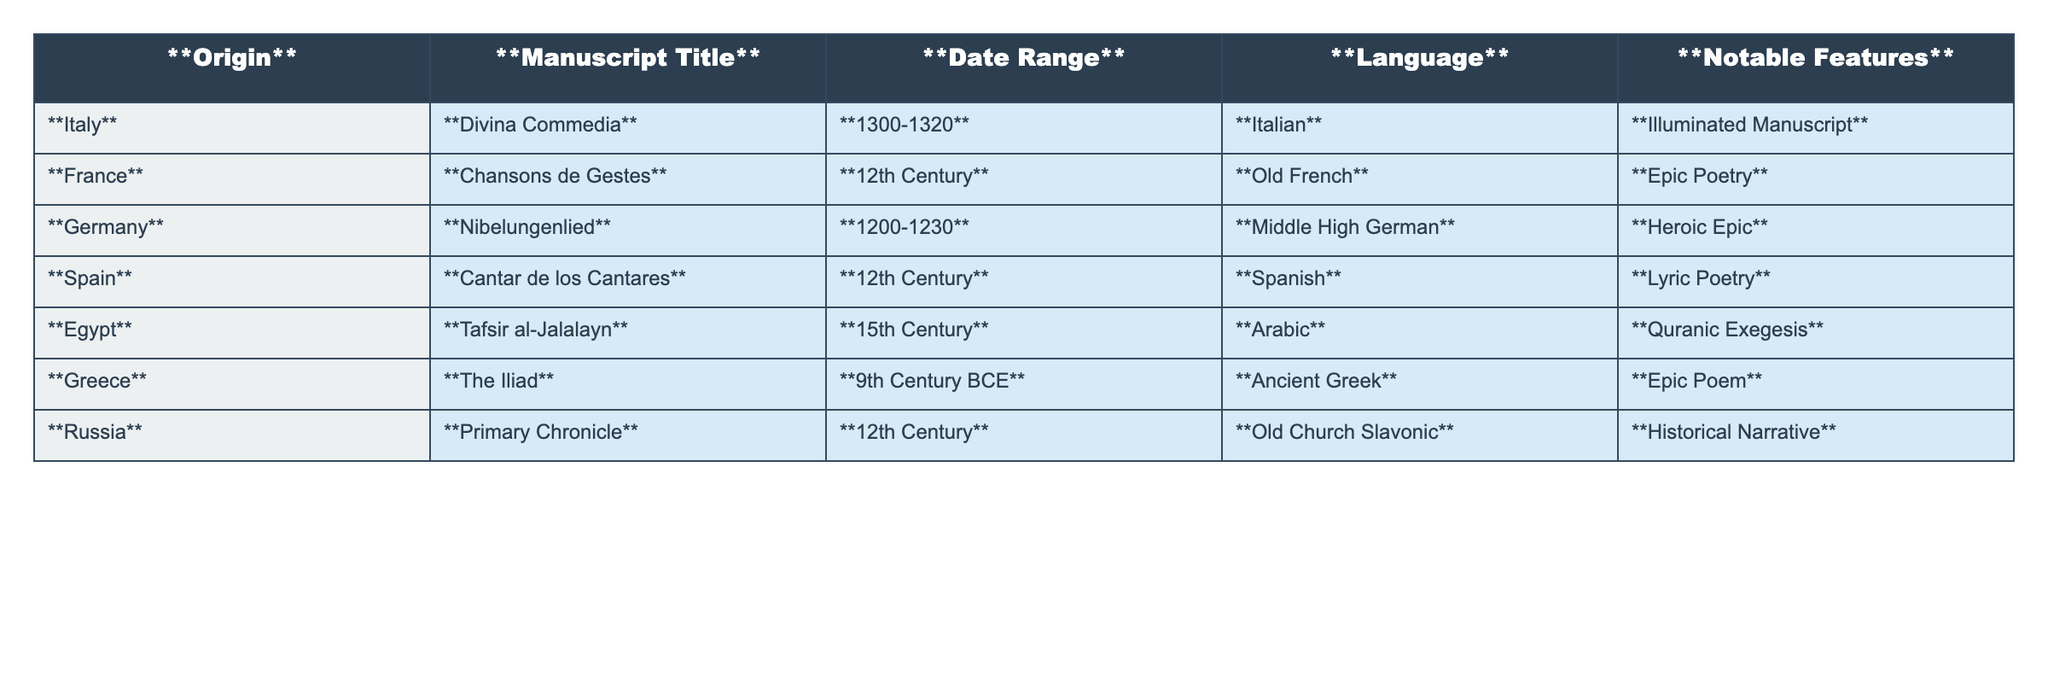What is the title of the manuscript from Egypt? The table lists the manuscripts by origin, and the entry for Egypt shows the manuscript titled "Tafsir al-Jalalayn."
Answer: Tafsir al-Jalalayn Which manuscript is written in Ancient Greek? Looking at the Language column, the entry for Ancient Greek corresponds to the manuscript titled "The Iliad" under Greece.
Answer: The Iliad How many manuscripts are from the 12th Century? The table lists two manuscripts dated to the 12th Century: "Chansons de Gestes" from France and "Cantar de los Cantares" from Spain.
Answer: Two Is the "Divina Commedia" an illuminated manuscript? The table indicates that "Divina Commedia," which is from Italy, has the notable feature of being an illuminated manuscript, confirming that it is indeed illuminated.
Answer: Yes What notable feature is associated with the "Nibelungenlied"? By reviewing the notable features column, it states that "Nibelungenlied," from Germany, is categorized as a heroic epic.
Answer: Heroic Epic What is the range of dates for the manuscript from Greece? The table shows that the manuscript "The Iliad" from Greece has a date range of "9th Century BCE."
Answer: 9th Century BCE Which language is used in the "Primary Chronicle"? The table indicates that the "Primary Chronicle," originating from Russia, is written in Old Church Slavonic.
Answer: Old Church Slavonic How many manuscripts are written in languages that are classified as Romance languages? Analyzing the table: "Divina Commedia" (Italian), "Chansons de Gestes" (Old French), and "Cantar de los Cantares" (Spanish) are all Romance languages, totaling three manuscripts.
Answer: Three What is the earliest date range among the manuscripts listed? Upon reviewing the date ranges, "The Iliad" from Greece is dated to the 9th Century BCE, making it the earliest.
Answer: 9th Century BCE Which origin has a manuscript that focuses on Quranic exegesis? From the table, it is evident that Egypt has a manuscript titled "Tafsir al-Jalalayn," which focuses on Quranic exegesis.
Answer: Egypt 